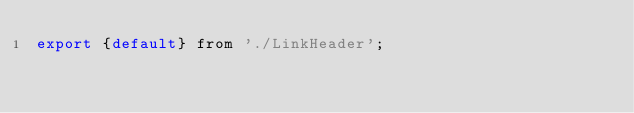<code> <loc_0><loc_0><loc_500><loc_500><_JavaScript_>export {default} from './LinkHeader';
</code> 